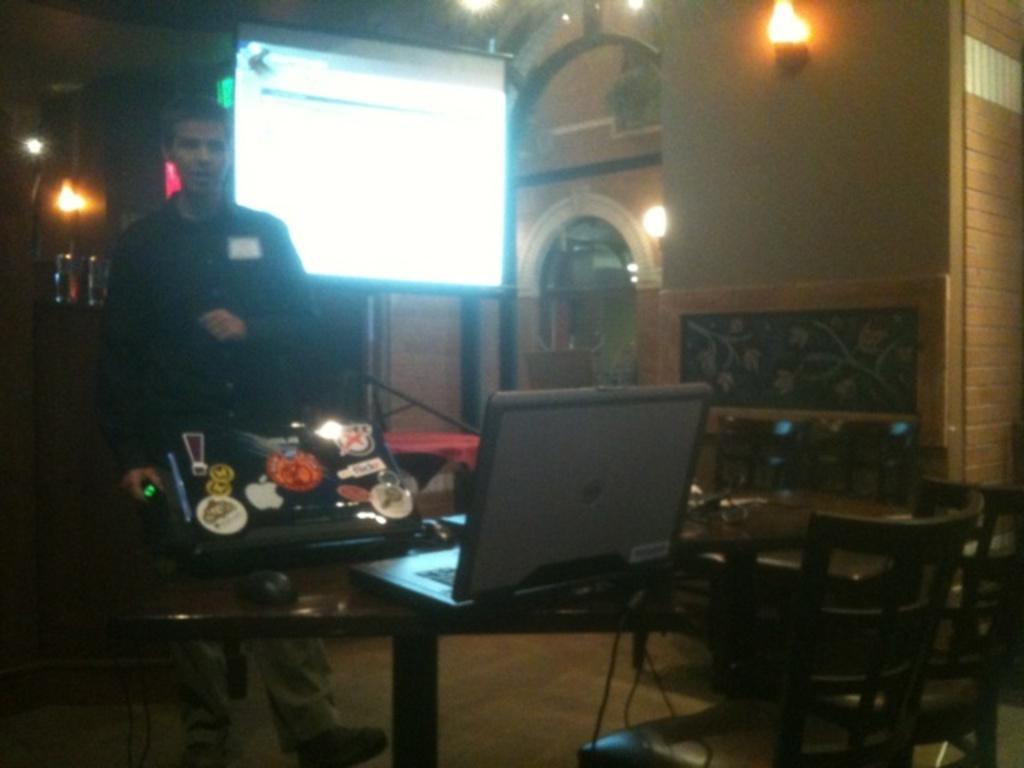In one or two sentences, can you explain what this image depicts? In this image the man is standing. On the table there is a laptop and there are chairs. 